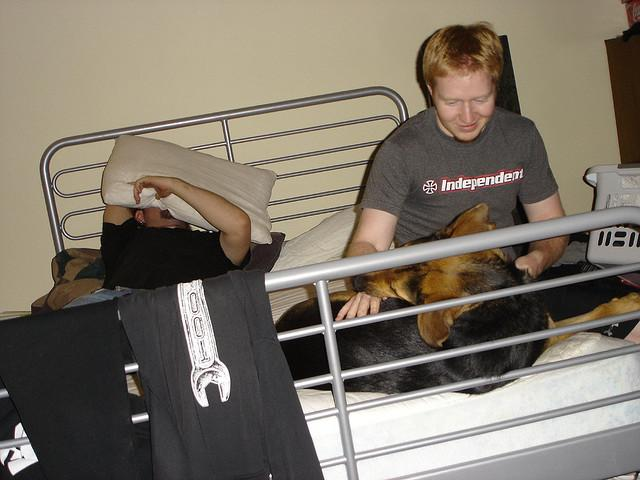What tool is printed on the shirt on the railing? wrench 